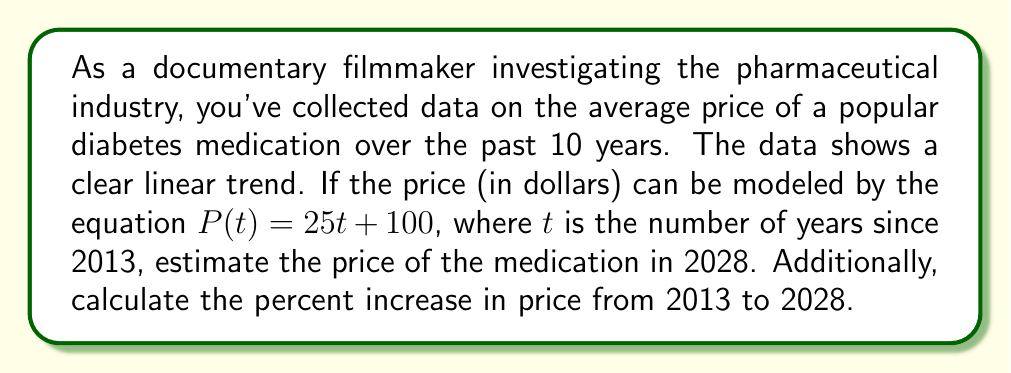Could you help me with this problem? To solve this problem, we'll follow these steps:

1. Determine the value of $t$ for the year 2028:
   2028 is 15 years after 2013, so $t = 15$

2. Calculate the price in 2028 using the given equation:
   $P(t) = 25t + 100$
   $P(15) = 25(15) + 100$
   $P(15) = 375 + 100 = 475$

3. Calculate the price in 2013 (when $t = 0$):
   $P(0) = 25(0) + 100 = 100$

4. Calculate the percent increase from 2013 to 2028:
   Percent increase = $\frac{\text{Increase}}{\text{Original Price}} \times 100\%$
   
   Increase = $475 - 100 = 375$
   
   Percent increase = $\frac{375}{100} \times 100\% = 375\%$

This analysis shows a significant increase in the price of the medication over 15 years, which could be a key point in your documentary about the pharmaceutical industry's pricing practices.
Answer: The estimated price of the medication in 2028 is $475. The percent increase in price from 2013 to 2028 is 375%. 